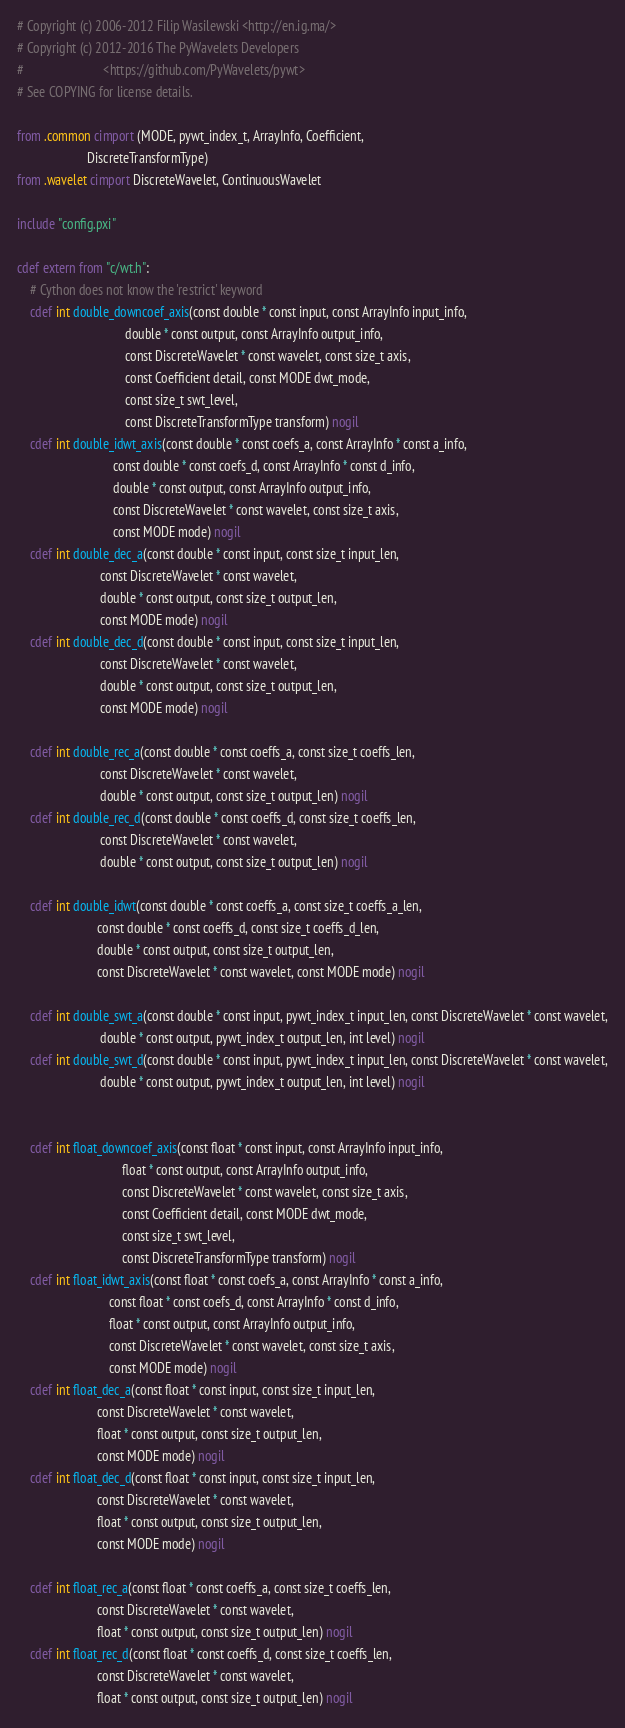<code> <loc_0><loc_0><loc_500><loc_500><_Cython_># Copyright (c) 2006-2012 Filip Wasilewski <http://en.ig.ma/>
# Copyright (c) 2012-2016 The PyWavelets Developers
#                         <https://github.com/PyWavelets/pywt>
# See COPYING for license details.

from .common cimport (MODE, pywt_index_t, ArrayInfo, Coefficient,
                      DiscreteTransformType)
from .wavelet cimport DiscreteWavelet, ContinuousWavelet

include "config.pxi"

cdef extern from "c/wt.h":
    # Cython does not know the 'restrict' keyword
    cdef int double_downcoef_axis(const double * const input, const ArrayInfo input_info,
                                  double * const output, const ArrayInfo output_info,
                                  const DiscreteWavelet * const wavelet, const size_t axis,
                                  const Coefficient detail, const MODE dwt_mode,
                                  const size_t swt_level,
                                  const DiscreteTransformType transform) nogil
    cdef int double_idwt_axis(const double * const coefs_a, const ArrayInfo * const a_info,
                              const double * const coefs_d, const ArrayInfo * const d_info,
                              double * const output, const ArrayInfo output_info,
                              const DiscreteWavelet * const wavelet, const size_t axis,
                              const MODE mode) nogil
    cdef int double_dec_a(const double * const input, const size_t input_len,
                          const DiscreteWavelet * const wavelet,
                          double * const output, const size_t output_len,
                          const MODE mode) nogil
    cdef int double_dec_d(const double * const input, const size_t input_len,
                          const DiscreteWavelet * const wavelet,
                          double * const output, const size_t output_len,
                          const MODE mode) nogil

    cdef int double_rec_a(const double * const coeffs_a, const size_t coeffs_len,
                          const DiscreteWavelet * const wavelet,
                          double * const output, const size_t output_len) nogil
    cdef int double_rec_d(const double * const coeffs_d, const size_t coeffs_len,
                          const DiscreteWavelet * const wavelet,
                          double * const output, const size_t output_len) nogil

    cdef int double_idwt(const double * const coeffs_a, const size_t coeffs_a_len,
                         const double * const coeffs_d, const size_t coeffs_d_len,
                         double * const output, const size_t output_len,
                         const DiscreteWavelet * const wavelet, const MODE mode) nogil

    cdef int double_swt_a(const double * const input, pywt_index_t input_len, const DiscreteWavelet * const wavelet,
                          double * const output, pywt_index_t output_len, int level) nogil
    cdef int double_swt_d(const double * const input, pywt_index_t input_len, const DiscreteWavelet * const wavelet,
                          double * const output, pywt_index_t output_len, int level) nogil


    cdef int float_downcoef_axis(const float * const input, const ArrayInfo input_info,
                                 float * const output, const ArrayInfo output_info,
                                 const DiscreteWavelet * const wavelet, const size_t axis,
                                 const Coefficient detail, const MODE dwt_mode,
                                 const size_t swt_level,
                                 const DiscreteTransformType transform) nogil
    cdef int float_idwt_axis(const float * const coefs_a, const ArrayInfo * const a_info,
                             const float * const coefs_d, const ArrayInfo * const d_info,
                             float * const output, const ArrayInfo output_info,
                             const DiscreteWavelet * const wavelet, const size_t axis,
                             const MODE mode) nogil
    cdef int float_dec_a(const float * const input, const size_t input_len,
                         const DiscreteWavelet * const wavelet,
                         float * const output, const size_t output_len,
                         const MODE mode) nogil
    cdef int float_dec_d(const float * const input, const size_t input_len,
                         const DiscreteWavelet * const wavelet,
                         float * const output, const size_t output_len,
                         const MODE mode) nogil

    cdef int float_rec_a(const float * const coeffs_a, const size_t coeffs_len,
                         const DiscreteWavelet * const wavelet,
                         float * const output, const size_t output_len) nogil
    cdef int float_rec_d(const float * const coeffs_d, const size_t coeffs_len,
                         const DiscreteWavelet * const wavelet,
                         float * const output, const size_t output_len) nogil
</code> 